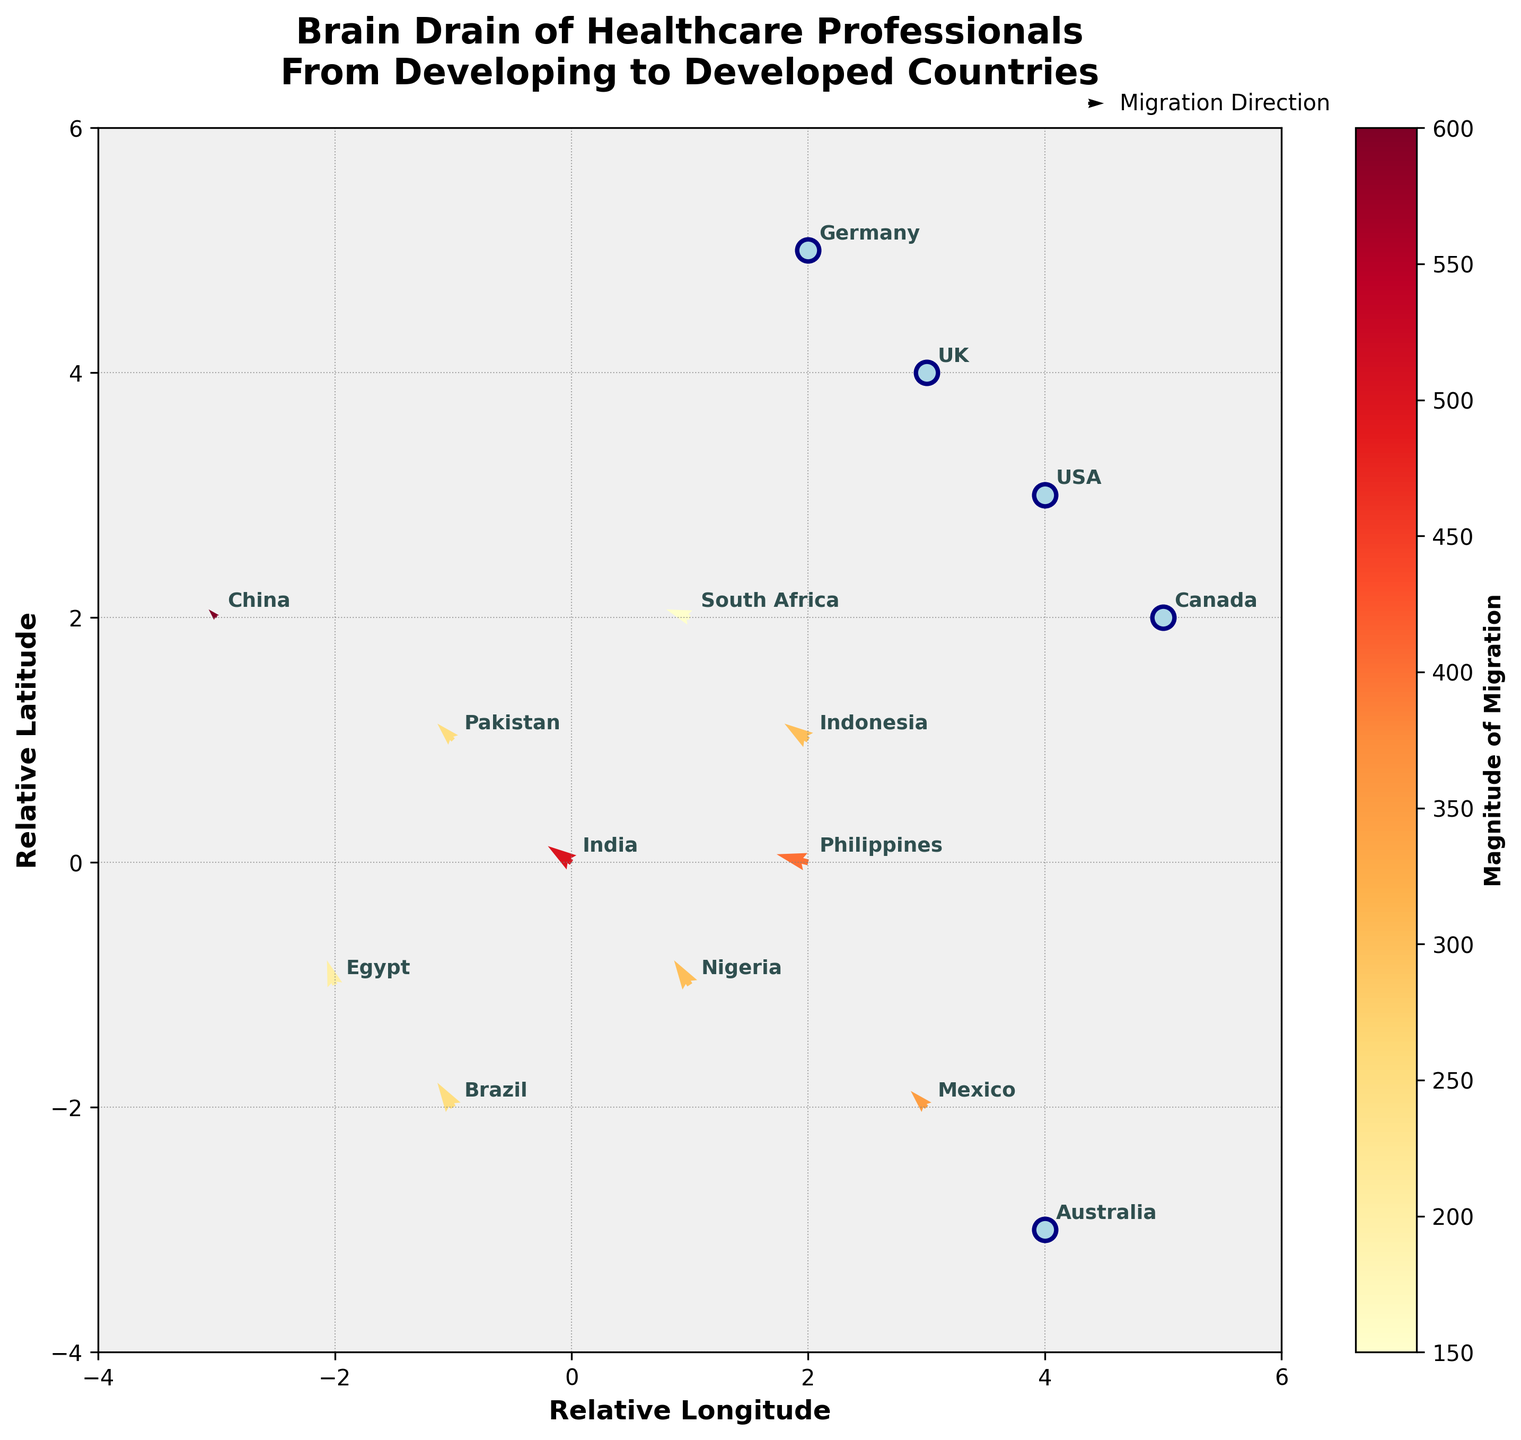What is the title of the plot? The title is usually placed at the top of the figure and encapsulates the primary focus. On the plot, the title is "Brain Drain of Healthcare Professionals From Developing to Developed Countries."
Answer: Brain Drain of Healthcare Professionals From Developing to Developed Countries Which countries are depicted as developed on the plot? Developed countries are indicated as scatter points in light blue. The plot shows USA, UK, Canada, Australia, and Germany as developed countries.
Answer: USA, UK, Canada, Australia, Germany Which country shows the largest magnitude of migration? The color bar on the plot indicates the magnitude of migration, with darker colors representing a higher magnitude. China has the highest magnitude of 600.
Answer: China What are the directions of migration for Indonesia and Philippines? Arrows in the quiver plot indicate the direction and length of migration. For Indonesia, the arrow points from (2, 1) to (2-3, 1+2) = (-1, 3). For the Philippines, it points from (2, 0) to (2-4, 0+1) = (-2, 1). Both move southwest, but Philippines has a more westward direction.
Answer: both southwest Which developing country has the smallest magnitude of migration, and what is its value? The color bar is darker for higher magnitudes and lighter for lower. South Africa’s color is the lightest among developing countries with a magnitude of 150.
Answer: South Africa, 150 How many countries show movement towards the northwest direction? Countries moving towards the northwest will have negative U and positive V in their vector components. India, Nigeria, Pakistan, Brazil, Egypt, and Indonesia have such vectors. Counting these countries gives six.
Answer: six For each developing country, what is the average magnitude of migration? Sum up the magnitudes and divide by the number of developing countries: (500 + 300 + 250 + 400 + 200 + 150 + 350 + 600 + 300 + 250) / 10. Calculating it gives (3300 / 10) = 330.
Answer: 330 Which developed country is located the furthest west on the plot? The west direction corresponds with the most negative X value. The UK is at (3, 4), while Germany is at (2, 5), Canada at (5, 2), Australia at (4, -3), and the USA at (4, 3). Germany is furthest west.
Answer: Germany Compare the magnitudes of migration for Mexico and the Philippines. Which is larger? By looking at the color bar and the magnitudes directly, Mexico has a magnitude of 350, while the Philippines has 400. Therefore, the Philippines' magnitude is larger.
Answer: Philippines What is the relative compass direction and magnitude of migration from India? From India, the vector components are U = -3 and V = 2. This implies a northwest direction, and referring to the data, the magnitude is 500.
Answer: northwest, 500 